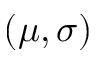<formula> <loc_0><loc_0><loc_500><loc_500>( \mu , \sigma )</formula> 